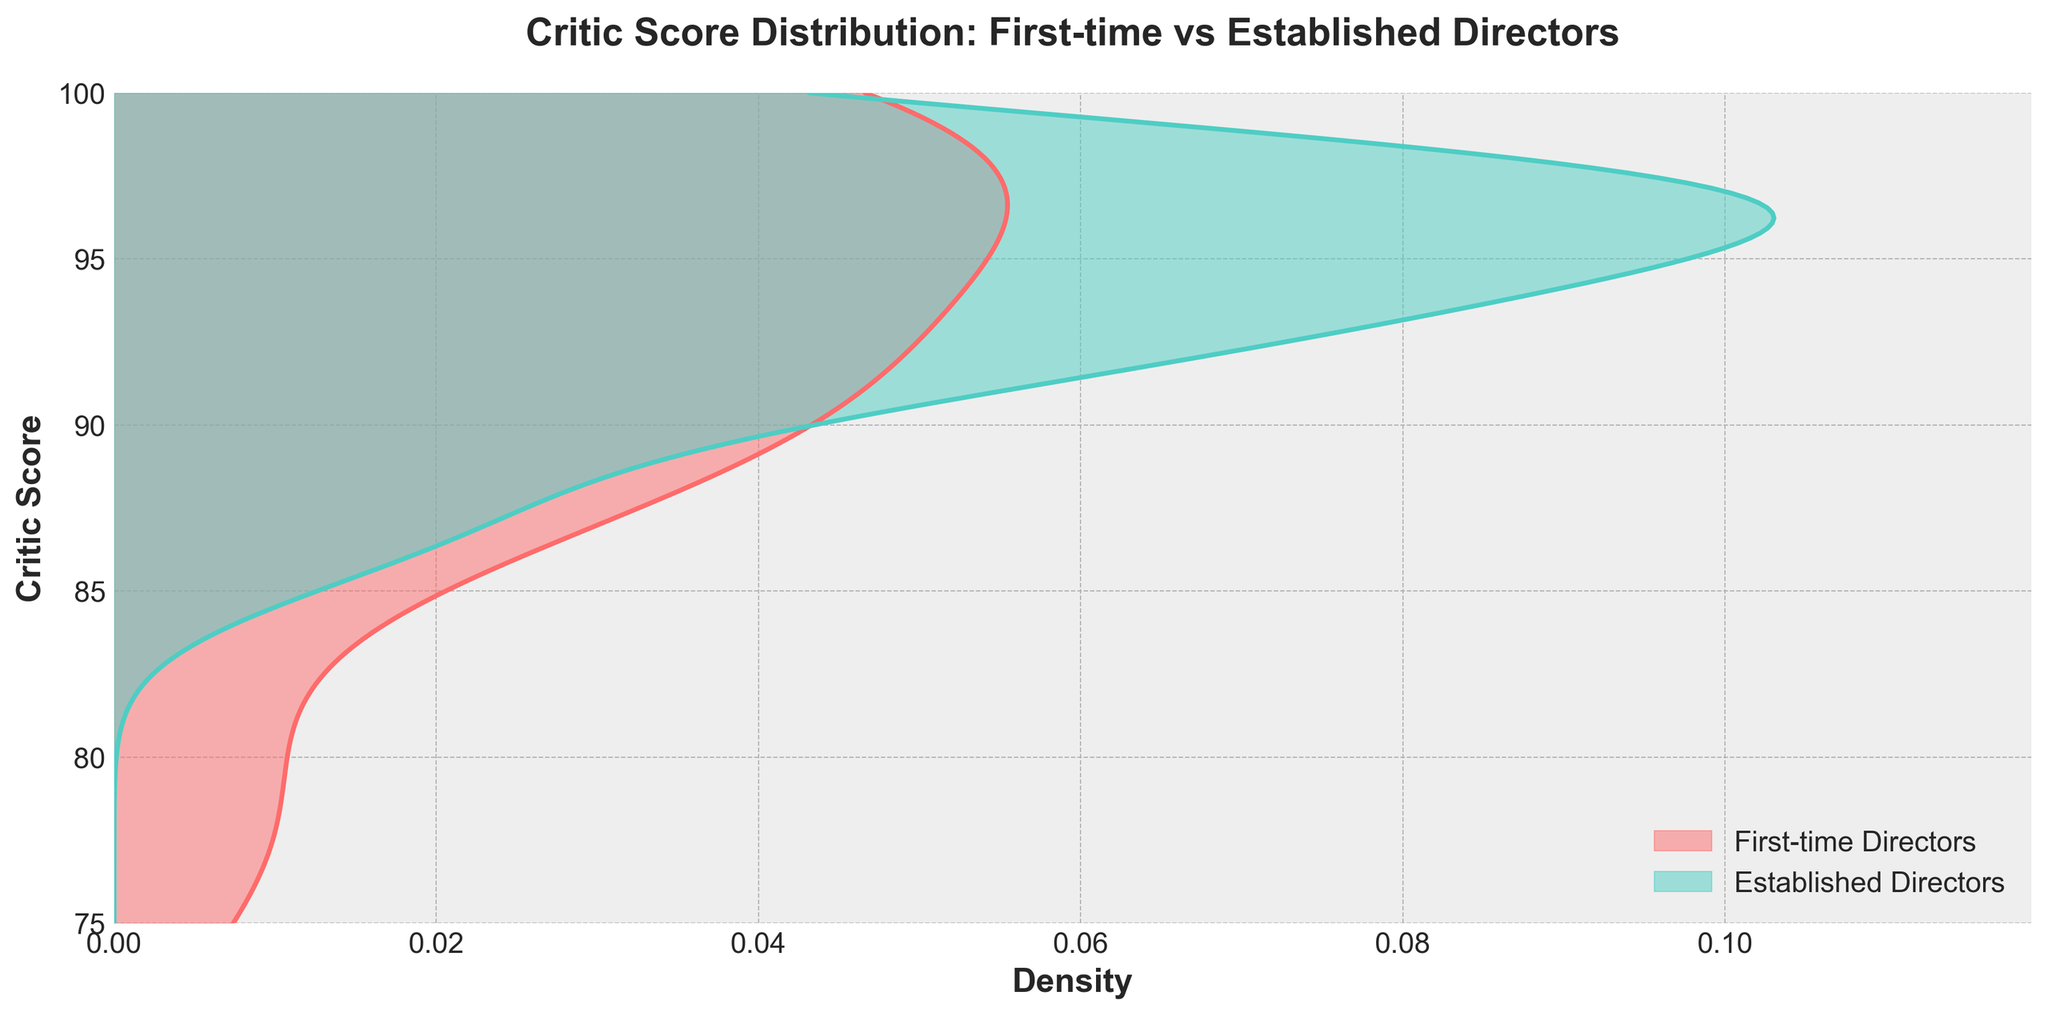What's the title of the plot? The title of the plot is located at the top and usually provides a brief description of what the plot data represents. Here, it reads "Critic Score Distribution: First-time vs Established Directors".
Answer: Critic Score Distribution: First-time vs Established Directors What does the x-axis represent? The label on the x-axis gives us an indication of what metric is being measured there. In this plot, the x-axis is labeled "Density".
Answer: Density Between which values does the y-axis range? The y-axis represents critic scores, and the vertical extent of the plot indicates the range of these scores. In this plot, the y-axis ranges from 75 to 100.
Answer: 75 to 100 Which color represents first-time directors? The plot typically uses a legend to map category labels to colors. According to the legend, first-time directors are represented by a redish color.
Answer: Redish color Which group of directors has the wider critic score distribution? By comparing the width and spread of the density plots, it's visible whether one group is more dispersed than the other. The density plot for first-time directors appears to spread across a wider range, indicating a wider distribution of critic scores.
Answer: First-time directors Which group of directors has a higher peak in density? To determine which group peaks higher, look for the maximum height reached by the density curves. The established director group has a higher peak, indicating more concentration of scores at certain values.
Answer: Established directors Is there overlap in critic scores between the two groups? Inspecting the plot carefully shows whether the density curves of first-time and established directors overlap, implying that both groups have some scores in common ranges. Both groups overlap significantly between the range of 85 to 98.
Answer: Yes Which group appears to have a higher average critic score based on the density plot? While the average is not directly shown, examining where the bulk of the density lies can provide a good estimate. The density plot for established directors is more centered around higher critic scores compared to first-time directors’.
Answer: Established directors What critic score seems to be the most common for first-time directors? The peak or mode of the density plot for first-time directors can be identified as the critic score with the highest density. This peak appears around a score of 99.
Answer: 99 During which critic score range do both groups have similar density levels? Finding the score or scores at which both density plots have approximately the same height will answer this. Between 85 and 90, the density plots for both directors are relatively comparable.
Answer: 85 to 90 